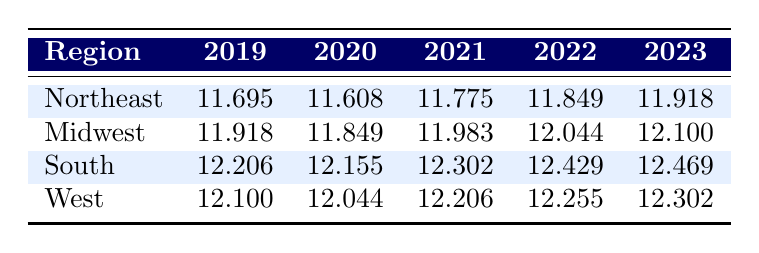What's the participation rate in youth sports for the South region in 2021? Looking at the table, the participation rate for the South in 2021 is listed directly under that year in the respective column. It shows a value of 12.302.
Answer: 12.302 What was the highest participation rate recorded in the Midwest region over the five years? The highest participation rate in the Midwest can be found by comparing all five years in the Midwest row. The values are 11.918, 11.849, 11.983, 12.044, and 12.100. The maximum value is 12.100 in 2023.
Answer: 12.100 Did the participation rate in the Northeast region increase every year from 2019 to 2023? By looking at the Northeast row, the participation rates for each year are 11.695, 11.608, 11.775, 11.849, and 11.918. The rates do not show a consistent increase every year, as there is a decrease from 2019 to 2020.
Answer: No What was the average participation rate in youth sports across all regions in 2022? To calculate the average participation rate for 2022, we first find the rates for each region: Northeast 11.849, Midwest 12.044, South 12.429, and West 12.255. Adding these gives 11.849 + 12.044 + 12.429 + 12.255 = 48.577. Dividing by 4 (the number of regions) gives an average of 12.14425, which rounds to 12.144.
Answer: 12.144 Which region had the lowest participation rate in 2020? By comparing the participation rates for 2020 across all regions: Northeast 11.608, Midwest 11.849, South 12.155, and West 12.044. The lowest value is 11.608 for the Northeast region.
Answer: Northeast What is the change in participation rate from 2019 to 2023 for the South region? The participation rates for the South in 2019 and 2023 are 12.206 and 12.469 respectively. The change is calculated by subtracting the 2019 rate from the 2023 rate: 12.469 - 12.206 = 0.263.
Answer: 0.263 Was there a year when the participation rate in the West region was higher than in the Midwest region? Looking at the West and Midwest rows, the West rates are 12.100 (2019), 12.044 (2020), 12.206 (2021), 12.255 (2022), and 12.302 (2023). The Midwest rates are 11.918 (2019), 11.849 (2020), 11.983 (2021), 12.044 (2022), and 12.100 (2023). The West region had higher rates than the Midwest in 2021, 2022, and 2023.
Answer: Yes 